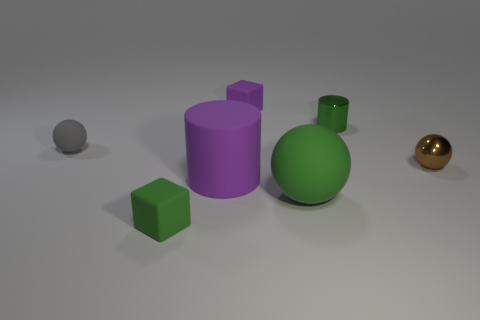Add 2 tiny gray objects. How many objects exist? 9 Subtract all cubes. How many objects are left? 5 Add 2 big purple matte things. How many big purple matte things exist? 3 Subtract 0 brown cylinders. How many objects are left? 7 Subtract all brown cylinders. Subtract all large green things. How many objects are left? 6 Add 1 big spheres. How many big spheres are left? 2 